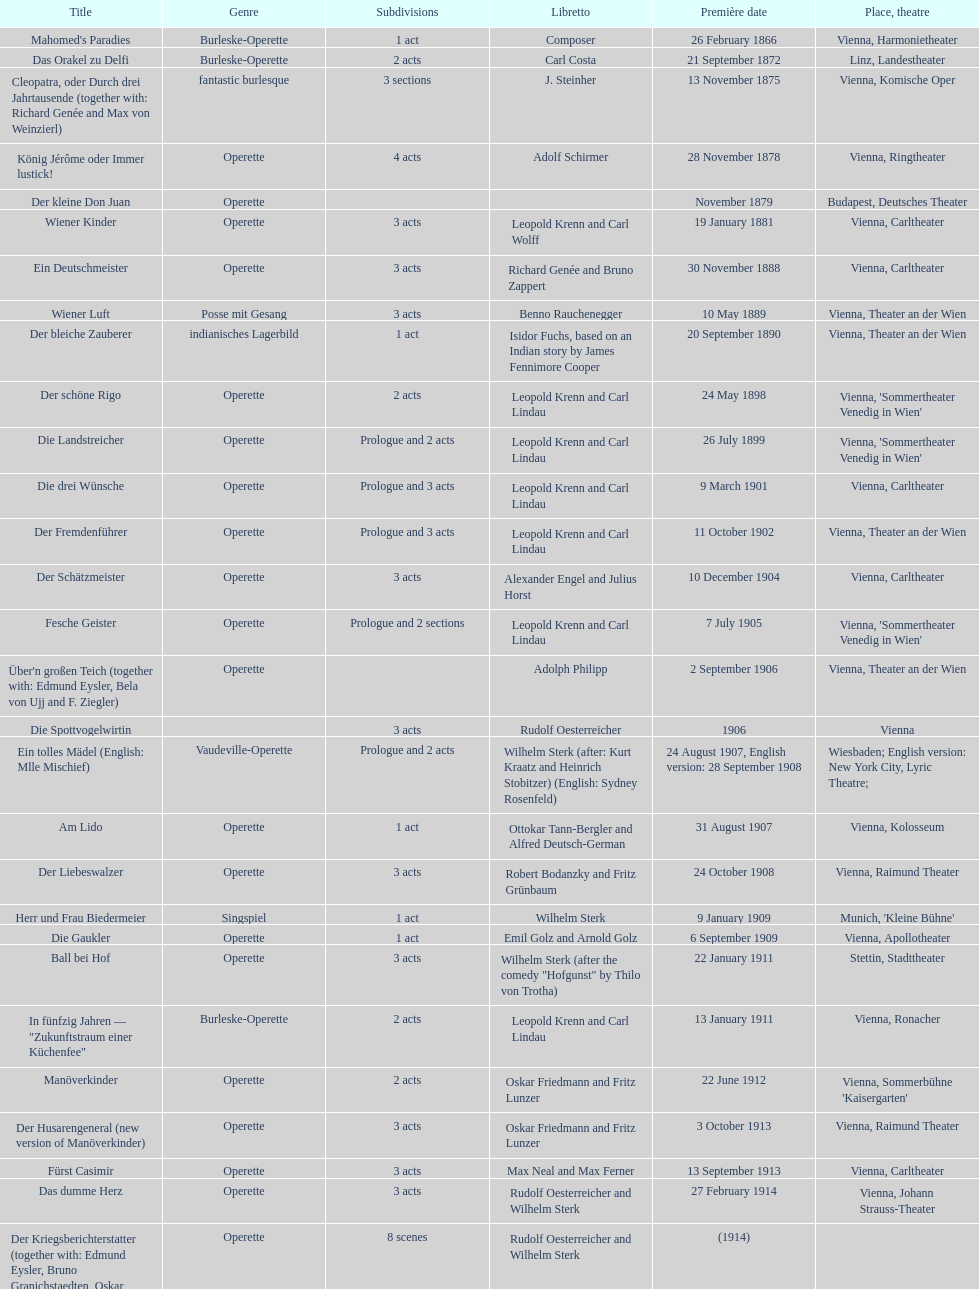Comparing der liebeswalzer and manöverkinder, which opera has more acts? Der Liebeswalzer. 